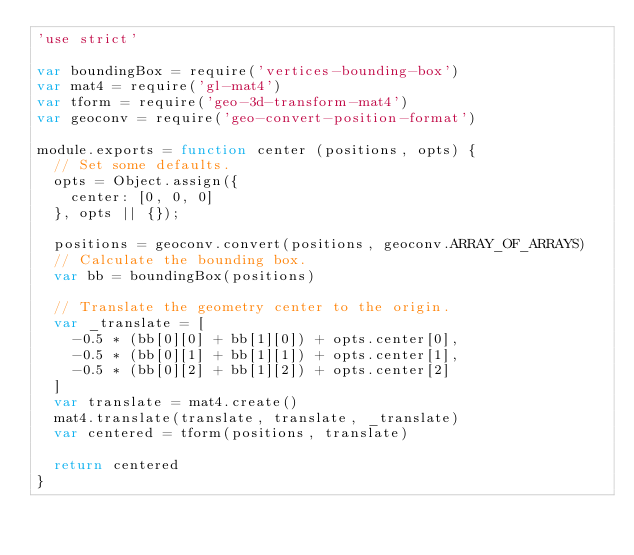Convert code to text. <code><loc_0><loc_0><loc_500><loc_500><_JavaScript_>'use strict'

var boundingBox = require('vertices-bounding-box')
var mat4 = require('gl-mat4')
var tform = require('geo-3d-transform-mat4')
var geoconv = require('geo-convert-position-format')

module.exports = function center (positions, opts) {
  // Set some defaults.
  opts = Object.assign({
    center: [0, 0, 0]
  }, opts || {});

  positions = geoconv.convert(positions, geoconv.ARRAY_OF_ARRAYS)
  // Calculate the bounding box.
  var bb = boundingBox(positions)

  // Translate the geometry center to the origin.
  var _translate = [
    -0.5 * (bb[0][0] + bb[1][0]) + opts.center[0],
    -0.5 * (bb[0][1] + bb[1][1]) + opts.center[1],
    -0.5 * (bb[0][2] + bb[1][2]) + opts.center[2]
  ]
  var translate = mat4.create()
  mat4.translate(translate, translate, _translate)
  var centered = tform(positions, translate)

  return centered
}
</code> 